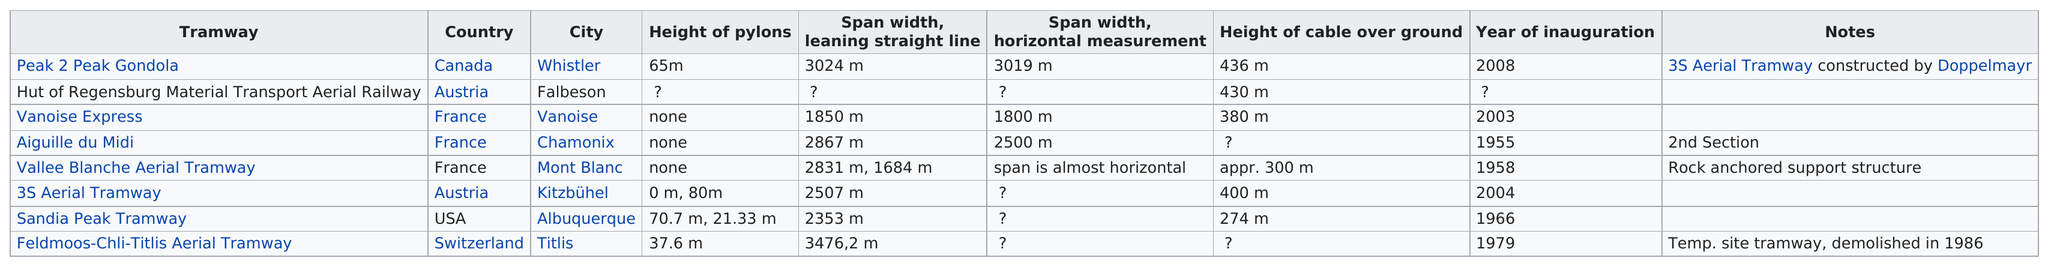Indicate a few pertinent items in this graphic. The number of aerial tramways inaugurated after 1970 is at least 4. The peak-to-peak gondola is significantly longer than the 32 aerial tramway, measuring 517 meters in length. The Sandia Peak Tramway was inaugurated before the 3S Aerial Tramway. The Aiguille du Midi tramway was inaugurated first, preceding the 3S aerial tramway. The height of the peak-to-peak gondola cable is significantly greater, at 56 meters, than that of the Vanoise Express, which measures 38.8 meters. 